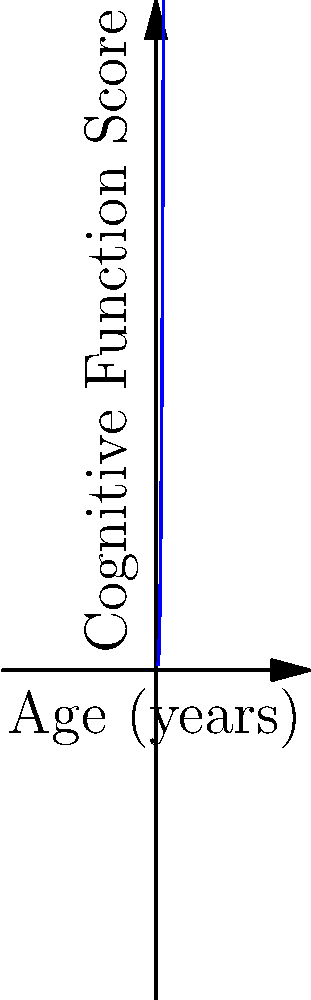The graph represents cognitive function scores over age using a polynomial trend line. If this trend continues, at approximately what age would cognitive function reach its lowest point? Explain your reasoning using the characteristics of polynomial functions. To find the age at which cognitive function reaches its lowest point, we need to analyze the polynomial function represented by the graph. Here's the step-by-step reasoning:

1. The graph shows a cubic polynomial function, as evidenced by the single turning point and the overall shape.

2. For a cubic function of the form $f(x) = ax^3 + bx^2 + cx + d$, where $a > 0$, the function will have a local minimum and a local maximum.

3. The age at which cognitive function is lowest corresponds to the local minimum of the function.

4. To find the local minimum, we need to find the point where the derivative of the function equals zero: $f'(x) = 0$.

5. For a cubic function, this occurs at the point where the curve changes from decreasing to increasing.

6. From the graph, we can see that the curve decreases from point A to point B, then increases from point B to point C.

7. Therefore, point B represents the local minimum of the function.

8. By estimating the x-coordinate of point B on the graph, we can see that it occurs at approximately 60 years of age.
Answer: Approximately 60 years old 